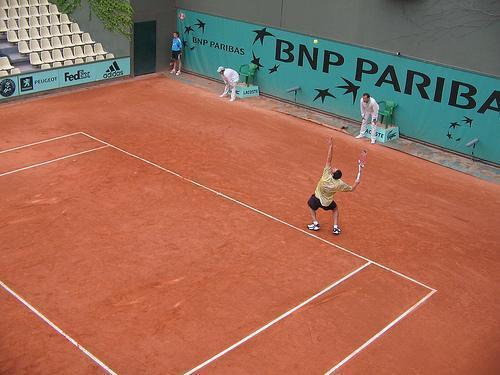How many players are shown?
Give a very brief answer. 1. How many people are sitting down?
Give a very brief answer. 0. 